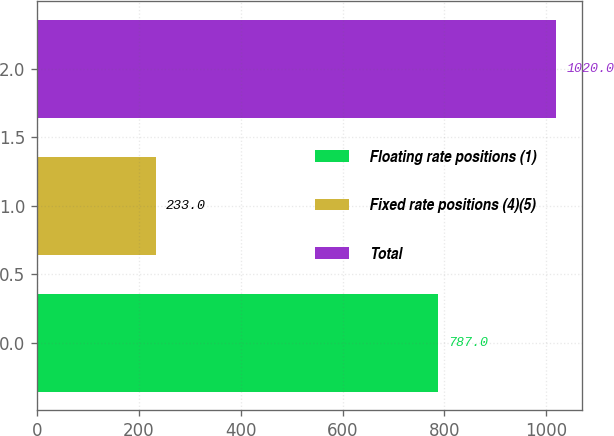Convert chart. <chart><loc_0><loc_0><loc_500><loc_500><bar_chart><fcel>Floating rate positions (1)<fcel>Fixed rate positions (4)(5)<fcel>Total<nl><fcel>787<fcel>233<fcel>1020<nl></chart> 